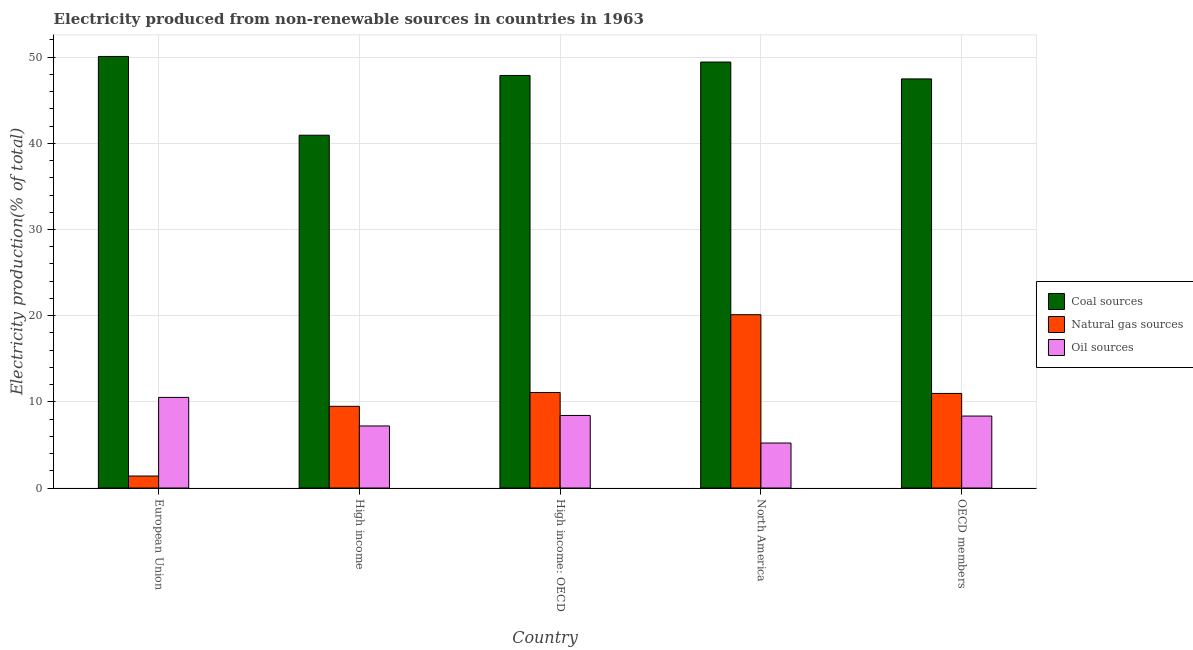How many groups of bars are there?
Your answer should be compact. 5. Are the number of bars per tick equal to the number of legend labels?
Make the answer very short. Yes. How many bars are there on the 2nd tick from the right?
Your response must be concise. 3. What is the label of the 3rd group of bars from the left?
Your answer should be very brief. High income: OECD. What is the percentage of electricity produced by oil sources in High income: OECD?
Your answer should be compact. 8.42. Across all countries, what is the maximum percentage of electricity produced by coal?
Ensure brevity in your answer.  50.08. Across all countries, what is the minimum percentage of electricity produced by coal?
Your response must be concise. 40.94. What is the total percentage of electricity produced by coal in the graph?
Offer a terse response. 235.8. What is the difference between the percentage of electricity produced by oil sources in High income: OECD and that in North America?
Provide a short and direct response. 3.2. What is the difference between the percentage of electricity produced by oil sources in High income: OECD and the percentage of electricity produced by natural gas in North America?
Your answer should be very brief. -11.69. What is the average percentage of electricity produced by coal per country?
Offer a very short reply. 47.16. What is the difference between the percentage of electricity produced by oil sources and percentage of electricity produced by natural gas in OECD members?
Give a very brief answer. -2.62. In how many countries, is the percentage of electricity produced by natural gas greater than 2 %?
Ensure brevity in your answer.  4. What is the ratio of the percentage of electricity produced by coal in European Union to that in High income?
Your response must be concise. 1.22. Is the percentage of electricity produced by oil sources in European Union less than that in High income: OECD?
Your answer should be compact. No. Is the difference between the percentage of electricity produced by natural gas in High income and North America greater than the difference between the percentage of electricity produced by coal in High income and North America?
Your answer should be very brief. No. What is the difference between the highest and the second highest percentage of electricity produced by oil sources?
Keep it short and to the point. 2.1. What is the difference between the highest and the lowest percentage of electricity produced by natural gas?
Offer a very short reply. 18.72. Is the sum of the percentage of electricity produced by coal in High income and North America greater than the maximum percentage of electricity produced by natural gas across all countries?
Ensure brevity in your answer.  Yes. What does the 3rd bar from the left in OECD members represents?
Your answer should be compact. Oil sources. What does the 2nd bar from the right in European Union represents?
Offer a very short reply. Natural gas sources. How many countries are there in the graph?
Your response must be concise. 5. What is the difference between two consecutive major ticks on the Y-axis?
Give a very brief answer. 10. How are the legend labels stacked?
Offer a terse response. Vertical. What is the title of the graph?
Your answer should be compact. Electricity produced from non-renewable sources in countries in 1963. What is the label or title of the Y-axis?
Offer a terse response. Electricity production(% of total). What is the Electricity production(% of total) of Coal sources in European Union?
Ensure brevity in your answer.  50.08. What is the Electricity production(% of total) of Natural gas sources in European Union?
Offer a terse response. 1.39. What is the Electricity production(% of total) of Oil sources in European Union?
Your answer should be very brief. 10.51. What is the Electricity production(% of total) in Coal sources in High income?
Provide a short and direct response. 40.94. What is the Electricity production(% of total) in Natural gas sources in High income?
Your response must be concise. 9.48. What is the Electricity production(% of total) of Oil sources in High income?
Offer a very short reply. 7.2. What is the Electricity production(% of total) of Coal sources in High income: OECD?
Keep it short and to the point. 47.87. What is the Electricity production(% of total) in Natural gas sources in High income: OECD?
Your answer should be very brief. 11.08. What is the Electricity production(% of total) of Oil sources in High income: OECD?
Make the answer very short. 8.42. What is the Electricity production(% of total) in Coal sources in North America?
Your answer should be compact. 49.43. What is the Electricity production(% of total) in Natural gas sources in North America?
Ensure brevity in your answer.  20.11. What is the Electricity production(% of total) of Oil sources in North America?
Offer a terse response. 5.22. What is the Electricity production(% of total) in Coal sources in OECD members?
Make the answer very short. 47.47. What is the Electricity production(% of total) of Natural gas sources in OECD members?
Your answer should be very brief. 10.97. What is the Electricity production(% of total) in Oil sources in OECD members?
Offer a terse response. 8.35. Across all countries, what is the maximum Electricity production(% of total) in Coal sources?
Offer a terse response. 50.08. Across all countries, what is the maximum Electricity production(% of total) in Natural gas sources?
Ensure brevity in your answer.  20.11. Across all countries, what is the maximum Electricity production(% of total) in Oil sources?
Give a very brief answer. 10.51. Across all countries, what is the minimum Electricity production(% of total) of Coal sources?
Ensure brevity in your answer.  40.94. Across all countries, what is the minimum Electricity production(% of total) in Natural gas sources?
Provide a succinct answer. 1.39. Across all countries, what is the minimum Electricity production(% of total) in Oil sources?
Make the answer very short. 5.22. What is the total Electricity production(% of total) in Coal sources in the graph?
Provide a succinct answer. 235.8. What is the total Electricity production(% of total) of Natural gas sources in the graph?
Offer a very short reply. 53.04. What is the total Electricity production(% of total) in Oil sources in the graph?
Ensure brevity in your answer.  39.7. What is the difference between the Electricity production(% of total) in Coal sources in European Union and that in High income?
Your response must be concise. 9.14. What is the difference between the Electricity production(% of total) of Natural gas sources in European Union and that in High income?
Offer a terse response. -8.09. What is the difference between the Electricity production(% of total) in Oil sources in European Union and that in High income?
Your response must be concise. 3.31. What is the difference between the Electricity production(% of total) of Coal sources in European Union and that in High income: OECD?
Provide a succinct answer. 2.21. What is the difference between the Electricity production(% of total) in Natural gas sources in European Union and that in High income: OECD?
Your response must be concise. -9.69. What is the difference between the Electricity production(% of total) of Oil sources in European Union and that in High income: OECD?
Give a very brief answer. 2.1. What is the difference between the Electricity production(% of total) of Coal sources in European Union and that in North America?
Offer a terse response. 0.65. What is the difference between the Electricity production(% of total) of Natural gas sources in European Union and that in North America?
Provide a short and direct response. -18.72. What is the difference between the Electricity production(% of total) of Oil sources in European Union and that in North America?
Give a very brief answer. 5.29. What is the difference between the Electricity production(% of total) in Coal sources in European Union and that in OECD members?
Your answer should be very brief. 2.61. What is the difference between the Electricity production(% of total) of Natural gas sources in European Union and that in OECD members?
Offer a very short reply. -9.58. What is the difference between the Electricity production(% of total) in Oil sources in European Union and that in OECD members?
Ensure brevity in your answer.  2.16. What is the difference between the Electricity production(% of total) of Coal sources in High income and that in High income: OECD?
Provide a succinct answer. -6.93. What is the difference between the Electricity production(% of total) of Natural gas sources in High income and that in High income: OECD?
Offer a very short reply. -1.61. What is the difference between the Electricity production(% of total) of Oil sources in High income and that in High income: OECD?
Offer a terse response. -1.22. What is the difference between the Electricity production(% of total) of Coal sources in High income and that in North America?
Ensure brevity in your answer.  -8.49. What is the difference between the Electricity production(% of total) in Natural gas sources in High income and that in North America?
Give a very brief answer. -10.63. What is the difference between the Electricity production(% of total) of Oil sources in High income and that in North America?
Give a very brief answer. 1.98. What is the difference between the Electricity production(% of total) in Coal sources in High income and that in OECD members?
Offer a terse response. -6.53. What is the difference between the Electricity production(% of total) of Natural gas sources in High income and that in OECD members?
Your answer should be compact. -1.5. What is the difference between the Electricity production(% of total) of Oil sources in High income and that in OECD members?
Make the answer very short. -1.15. What is the difference between the Electricity production(% of total) in Coal sources in High income: OECD and that in North America?
Offer a terse response. -1.56. What is the difference between the Electricity production(% of total) in Natural gas sources in High income: OECD and that in North America?
Provide a succinct answer. -9.03. What is the difference between the Electricity production(% of total) of Oil sources in High income: OECD and that in North America?
Offer a terse response. 3.2. What is the difference between the Electricity production(% of total) of Coal sources in High income: OECD and that in OECD members?
Provide a short and direct response. 0.4. What is the difference between the Electricity production(% of total) of Natural gas sources in High income: OECD and that in OECD members?
Provide a short and direct response. 0.11. What is the difference between the Electricity production(% of total) of Oil sources in High income: OECD and that in OECD members?
Keep it short and to the point. 0.07. What is the difference between the Electricity production(% of total) in Coal sources in North America and that in OECD members?
Your answer should be compact. 1.96. What is the difference between the Electricity production(% of total) of Natural gas sources in North America and that in OECD members?
Offer a very short reply. 9.14. What is the difference between the Electricity production(% of total) of Oil sources in North America and that in OECD members?
Make the answer very short. -3.13. What is the difference between the Electricity production(% of total) of Coal sources in European Union and the Electricity production(% of total) of Natural gas sources in High income?
Give a very brief answer. 40.6. What is the difference between the Electricity production(% of total) of Coal sources in European Union and the Electricity production(% of total) of Oil sources in High income?
Give a very brief answer. 42.88. What is the difference between the Electricity production(% of total) in Natural gas sources in European Union and the Electricity production(% of total) in Oil sources in High income?
Your response must be concise. -5.81. What is the difference between the Electricity production(% of total) in Coal sources in European Union and the Electricity production(% of total) in Natural gas sources in High income: OECD?
Offer a very short reply. 39. What is the difference between the Electricity production(% of total) in Coal sources in European Union and the Electricity production(% of total) in Oil sources in High income: OECD?
Provide a succinct answer. 41.66. What is the difference between the Electricity production(% of total) of Natural gas sources in European Union and the Electricity production(% of total) of Oil sources in High income: OECD?
Offer a very short reply. -7.03. What is the difference between the Electricity production(% of total) of Coal sources in European Union and the Electricity production(% of total) of Natural gas sources in North America?
Your response must be concise. 29.97. What is the difference between the Electricity production(% of total) in Coal sources in European Union and the Electricity production(% of total) in Oil sources in North America?
Your answer should be very brief. 44.86. What is the difference between the Electricity production(% of total) in Natural gas sources in European Union and the Electricity production(% of total) in Oil sources in North America?
Your response must be concise. -3.83. What is the difference between the Electricity production(% of total) in Coal sources in European Union and the Electricity production(% of total) in Natural gas sources in OECD members?
Offer a very short reply. 39.11. What is the difference between the Electricity production(% of total) of Coal sources in European Union and the Electricity production(% of total) of Oil sources in OECD members?
Your response must be concise. 41.73. What is the difference between the Electricity production(% of total) in Natural gas sources in European Union and the Electricity production(% of total) in Oil sources in OECD members?
Your answer should be very brief. -6.96. What is the difference between the Electricity production(% of total) of Coal sources in High income and the Electricity production(% of total) of Natural gas sources in High income: OECD?
Make the answer very short. 29.86. What is the difference between the Electricity production(% of total) in Coal sources in High income and the Electricity production(% of total) in Oil sources in High income: OECD?
Provide a short and direct response. 32.52. What is the difference between the Electricity production(% of total) in Natural gas sources in High income and the Electricity production(% of total) in Oil sources in High income: OECD?
Keep it short and to the point. 1.06. What is the difference between the Electricity production(% of total) of Coal sources in High income and the Electricity production(% of total) of Natural gas sources in North America?
Make the answer very short. 20.83. What is the difference between the Electricity production(% of total) in Coal sources in High income and the Electricity production(% of total) in Oil sources in North America?
Provide a short and direct response. 35.72. What is the difference between the Electricity production(% of total) in Natural gas sources in High income and the Electricity production(% of total) in Oil sources in North America?
Provide a succinct answer. 4.26. What is the difference between the Electricity production(% of total) of Coal sources in High income and the Electricity production(% of total) of Natural gas sources in OECD members?
Offer a terse response. 29.96. What is the difference between the Electricity production(% of total) of Coal sources in High income and the Electricity production(% of total) of Oil sources in OECD members?
Your response must be concise. 32.59. What is the difference between the Electricity production(% of total) of Natural gas sources in High income and the Electricity production(% of total) of Oil sources in OECD members?
Your answer should be very brief. 1.13. What is the difference between the Electricity production(% of total) of Coal sources in High income: OECD and the Electricity production(% of total) of Natural gas sources in North America?
Ensure brevity in your answer.  27.76. What is the difference between the Electricity production(% of total) in Coal sources in High income: OECD and the Electricity production(% of total) in Oil sources in North America?
Ensure brevity in your answer.  42.65. What is the difference between the Electricity production(% of total) of Natural gas sources in High income: OECD and the Electricity production(% of total) of Oil sources in North America?
Your answer should be compact. 5.86. What is the difference between the Electricity production(% of total) of Coal sources in High income: OECD and the Electricity production(% of total) of Natural gas sources in OECD members?
Provide a succinct answer. 36.9. What is the difference between the Electricity production(% of total) of Coal sources in High income: OECD and the Electricity production(% of total) of Oil sources in OECD members?
Your answer should be compact. 39.52. What is the difference between the Electricity production(% of total) of Natural gas sources in High income: OECD and the Electricity production(% of total) of Oil sources in OECD members?
Give a very brief answer. 2.73. What is the difference between the Electricity production(% of total) of Coal sources in North America and the Electricity production(% of total) of Natural gas sources in OECD members?
Give a very brief answer. 38.46. What is the difference between the Electricity production(% of total) of Coal sources in North America and the Electricity production(% of total) of Oil sources in OECD members?
Keep it short and to the point. 41.08. What is the difference between the Electricity production(% of total) of Natural gas sources in North America and the Electricity production(% of total) of Oil sources in OECD members?
Ensure brevity in your answer.  11.76. What is the average Electricity production(% of total) of Coal sources per country?
Your response must be concise. 47.16. What is the average Electricity production(% of total) in Natural gas sources per country?
Make the answer very short. 10.61. What is the average Electricity production(% of total) in Oil sources per country?
Provide a short and direct response. 7.94. What is the difference between the Electricity production(% of total) in Coal sources and Electricity production(% of total) in Natural gas sources in European Union?
Keep it short and to the point. 48.69. What is the difference between the Electricity production(% of total) in Coal sources and Electricity production(% of total) in Oil sources in European Union?
Offer a terse response. 39.57. What is the difference between the Electricity production(% of total) in Natural gas sources and Electricity production(% of total) in Oil sources in European Union?
Your response must be concise. -9.12. What is the difference between the Electricity production(% of total) of Coal sources and Electricity production(% of total) of Natural gas sources in High income?
Give a very brief answer. 31.46. What is the difference between the Electricity production(% of total) of Coal sources and Electricity production(% of total) of Oil sources in High income?
Ensure brevity in your answer.  33.74. What is the difference between the Electricity production(% of total) in Natural gas sources and Electricity production(% of total) in Oil sources in High income?
Your response must be concise. 2.28. What is the difference between the Electricity production(% of total) of Coal sources and Electricity production(% of total) of Natural gas sources in High income: OECD?
Your answer should be very brief. 36.79. What is the difference between the Electricity production(% of total) in Coal sources and Electricity production(% of total) in Oil sources in High income: OECD?
Your answer should be compact. 39.45. What is the difference between the Electricity production(% of total) of Natural gas sources and Electricity production(% of total) of Oil sources in High income: OECD?
Provide a succinct answer. 2.66. What is the difference between the Electricity production(% of total) of Coal sources and Electricity production(% of total) of Natural gas sources in North America?
Offer a very short reply. 29.32. What is the difference between the Electricity production(% of total) in Coal sources and Electricity production(% of total) in Oil sources in North America?
Offer a terse response. 44.21. What is the difference between the Electricity production(% of total) of Natural gas sources and Electricity production(% of total) of Oil sources in North America?
Your response must be concise. 14.89. What is the difference between the Electricity production(% of total) of Coal sources and Electricity production(% of total) of Natural gas sources in OECD members?
Make the answer very short. 36.5. What is the difference between the Electricity production(% of total) in Coal sources and Electricity production(% of total) in Oil sources in OECD members?
Provide a succinct answer. 39.12. What is the difference between the Electricity production(% of total) of Natural gas sources and Electricity production(% of total) of Oil sources in OECD members?
Offer a very short reply. 2.62. What is the ratio of the Electricity production(% of total) in Coal sources in European Union to that in High income?
Ensure brevity in your answer.  1.22. What is the ratio of the Electricity production(% of total) in Natural gas sources in European Union to that in High income?
Your response must be concise. 0.15. What is the ratio of the Electricity production(% of total) of Oil sources in European Union to that in High income?
Provide a short and direct response. 1.46. What is the ratio of the Electricity production(% of total) of Coal sources in European Union to that in High income: OECD?
Make the answer very short. 1.05. What is the ratio of the Electricity production(% of total) of Natural gas sources in European Union to that in High income: OECD?
Offer a very short reply. 0.13. What is the ratio of the Electricity production(% of total) in Oil sources in European Union to that in High income: OECD?
Ensure brevity in your answer.  1.25. What is the ratio of the Electricity production(% of total) in Coal sources in European Union to that in North America?
Your response must be concise. 1.01. What is the ratio of the Electricity production(% of total) in Natural gas sources in European Union to that in North America?
Your answer should be very brief. 0.07. What is the ratio of the Electricity production(% of total) in Oil sources in European Union to that in North America?
Give a very brief answer. 2.01. What is the ratio of the Electricity production(% of total) in Coal sources in European Union to that in OECD members?
Give a very brief answer. 1.05. What is the ratio of the Electricity production(% of total) in Natural gas sources in European Union to that in OECD members?
Provide a short and direct response. 0.13. What is the ratio of the Electricity production(% of total) in Oil sources in European Union to that in OECD members?
Ensure brevity in your answer.  1.26. What is the ratio of the Electricity production(% of total) in Coal sources in High income to that in High income: OECD?
Provide a short and direct response. 0.86. What is the ratio of the Electricity production(% of total) of Natural gas sources in High income to that in High income: OECD?
Give a very brief answer. 0.86. What is the ratio of the Electricity production(% of total) of Oil sources in High income to that in High income: OECD?
Offer a very short reply. 0.86. What is the ratio of the Electricity production(% of total) of Coal sources in High income to that in North America?
Provide a succinct answer. 0.83. What is the ratio of the Electricity production(% of total) of Natural gas sources in High income to that in North America?
Provide a short and direct response. 0.47. What is the ratio of the Electricity production(% of total) in Oil sources in High income to that in North America?
Ensure brevity in your answer.  1.38. What is the ratio of the Electricity production(% of total) in Coal sources in High income to that in OECD members?
Offer a terse response. 0.86. What is the ratio of the Electricity production(% of total) of Natural gas sources in High income to that in OECD members?
Offer a terse response. 0.86. What is the ratio of the Electricity production(% of total) of Oil sources in High income to that in OECD members?
Your response must be concise. 0.86. What is the ratio of the Electricity production(% of total) in Coal sources in High income: OECD to that in North America?
Your answer should be very brief. 0.97. What is the ratio of the Electricity production(% of total) of Natural gas sources in High income: OECD to that in North America?
Your answer should be very brief. 0.55. What is the ratio of the Electricity production(% of total) in Oil sources in High income: OECD to that in North America?
Keep it short and to the point. 1.61. What is the ratio of the Electricity production(% of total) of Coal sources in High income: OECD to that in OECD members?
Provide a succinct answer. 1.01. What is the ratio of the Electricity production(% of total) of Natural gas sources in High income: OECD to that in OECD members?
Keep it short and to the point. 1.01. What is the ratio of the Electricity production(% of total) in Oil sources in High income: OECD to that in OECD members?
Offer a very short reply. 1.01. What is the ratio of the Electricity production(% of total) in Coal sources in North America to that in OECD members?
Your response must be concise. 1.04. What is the ratio of the Electricity production(% of total) of Natural gas sources in North America to that in OECD members?
Offer a terse response. 1.83. What is the ratio of the Electricity production(% of total) in Oil sources in North America to that in OECD members?
Keep it short and to the point. 0.63. What is the difference between the highest and the second highest Electricity production(% of total) in Coal sources?
Give a very brief answer. 0.65. What is the difference between the highest and the second highest Electricity production(% of total) in Natural gas sources?
Give a very brief answer. 9.03. What is the difference between the highest and the second highest Electricity production(% of total) in Oil sources?
Provide a short and direct response. 2.1. What is the difference between the highest and the lowest Electricity production(% of total) in Coal sources?
Ensure brevity in your answer.  9.14. What is the difference between the highest and the lowest Electricity production(% of total) in Natural gas sources?
Offer a terse response. 18.72. What is the difference between the highest and the lowest Electricity production(% of total) of Oil sources?
Offer a terse response. 5.29. 